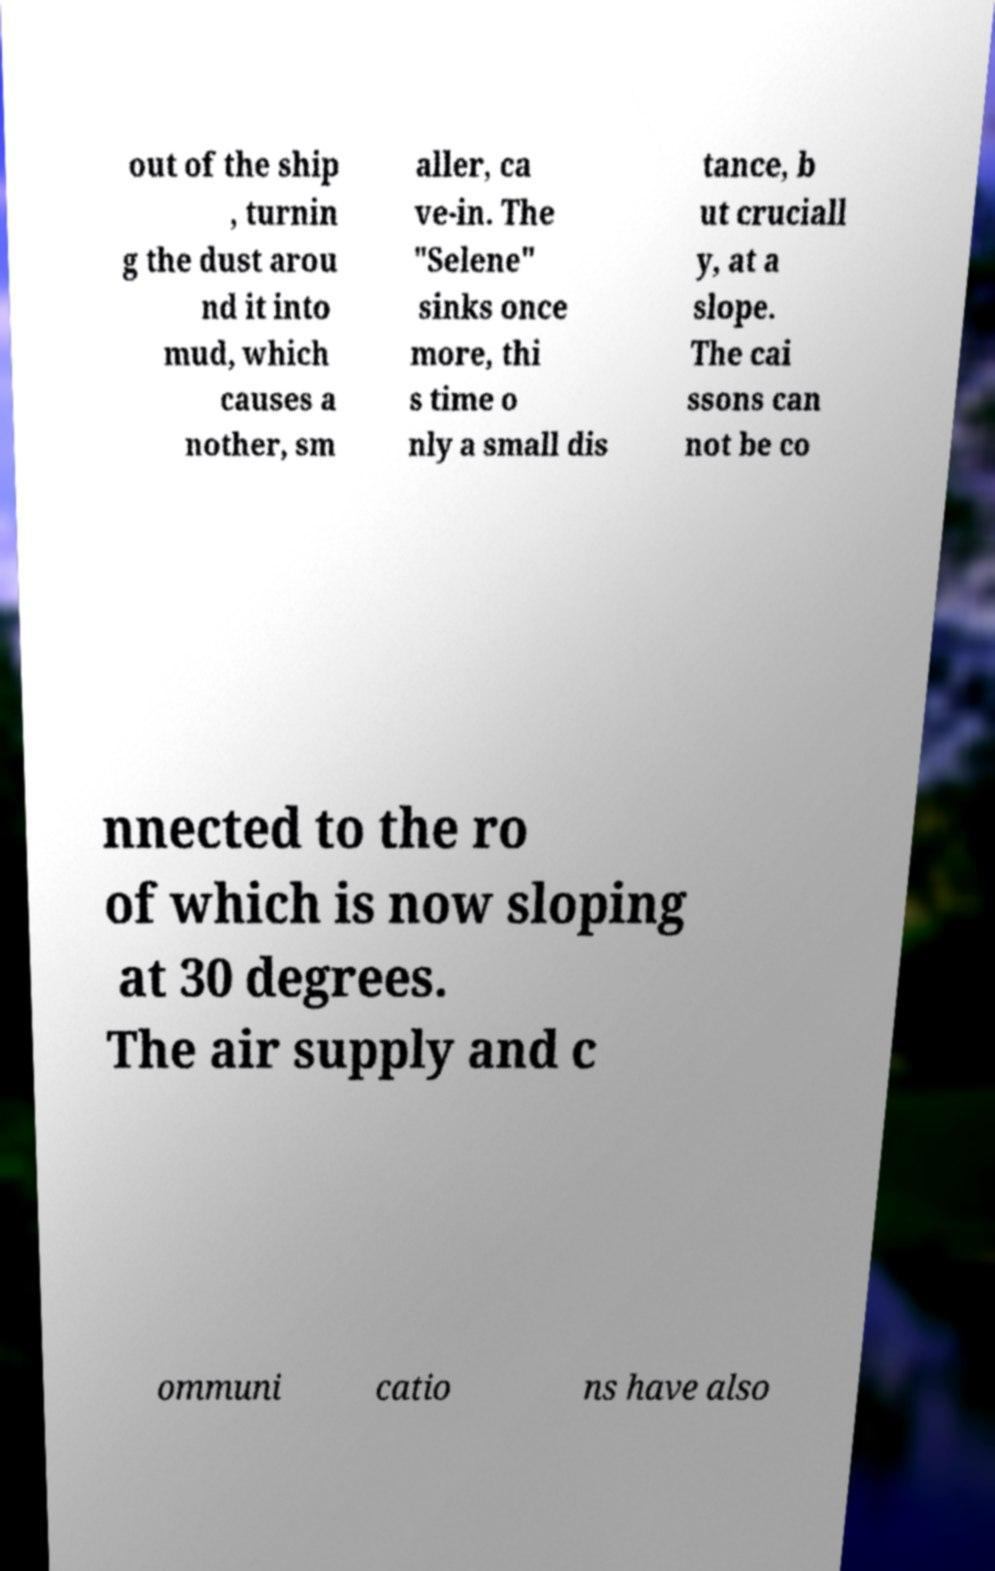For documentation purposes, I need the text within this image transcribed. Could you provide that? out of the ship , turnin g the dust arou nd it into mud, which causes a nother, sm aller, ca ve-in. The "Selene" sinks once more, thi s time o nly a small dis tance, b ut cruciall y, at a slope. The cai ssons can not be co nnected to the ro of which is now sloping at 30 degrees. The air supply and c ommuni catio ns have also 